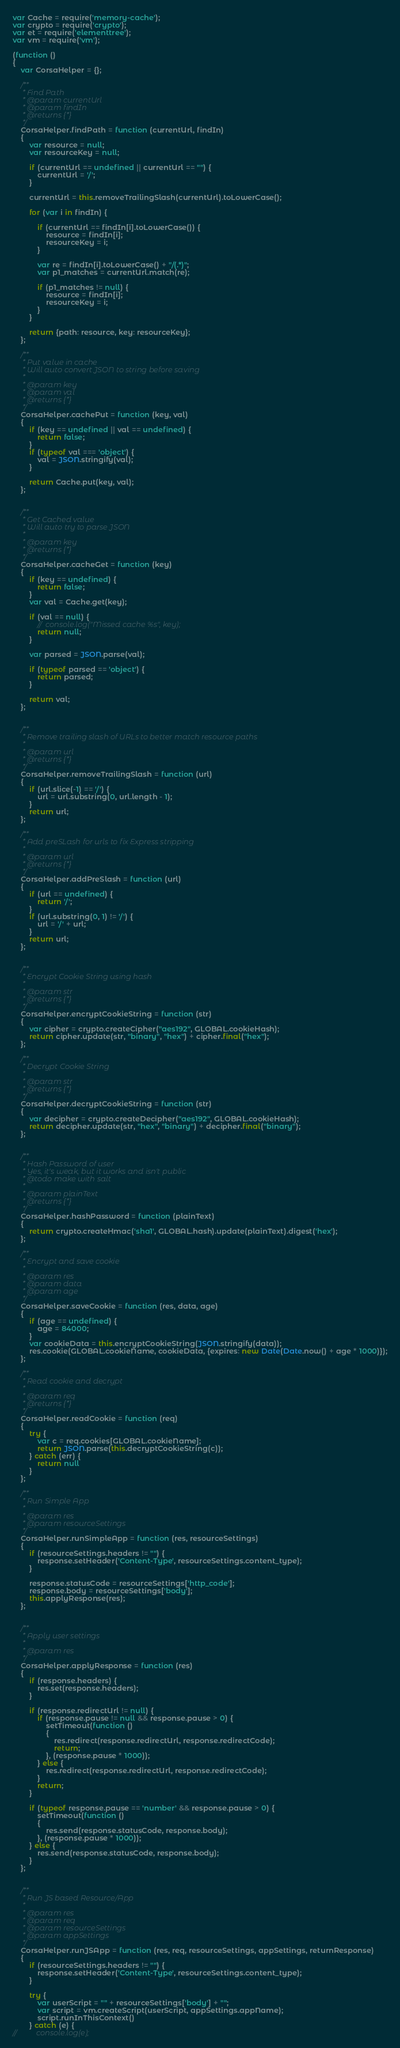Convert code to text. <code><loc_0><loc_0><loc_500><loc_500><_JavaScript_>var Cache = require('memory-cache');
var crypto = require('crypto');
var et = require('elementtree');
var vm = require('vm');

(function ()
{
	var CorsaHelper = {};

	/**
	 * Find Path
	 * @param currentUrl
	 * @param findIn
	 * @returns {*}
	 */
	CorsaHelper.findPath = function (currentUrl, findIn)
	{
		var resource = null;
		var resourceKey = null;

		if (currentUrl == undefined || currentUrl == "") {
			currentUrl = '/';
		}

		currentUrl = this.removeTrailingSlash(currentUrl).toLowerCase();

		for (var i in findIn) {

			if (currentUrl == findIn[i].toLowerCase()) {
				resource = findIn[i];
				resourceKey = i;
			}

			var re = findIn[i].toLowerCase() + "/(.*)";
			var p1_matches = currentUrl.match(re);

			if (p1_matches != null) {
				resource = findIn[i];
				resourceKey = i;
			}
		}

		return {path: resource, key: resourceKey};
	};

	/**
	 * Put value in cache
	 * Will auto convert JSON to string before saving
	 *
	 * @param key
	 * @param val
	 * @returns {*}
	 */
	CorsaHelper.cachePut = function (key, val)
	{
		if (key == undefined || val == undefined) {
			return false;
		}
		if (typeof val === 'object') {
			val = JSON.stringify(val);
		}

		return Cache.put(key, val);
	};


	/**
	 * Get Cached value
	 * Will auto try to parse JSON
	 *
	 * @param key
	 * @returns {*}
	 */
	CorsaHelper.cacheGet = function (key)
	{
		if (key == undefined) {
			return false;
		}
		var val = Cache.get(key);

		if (val == null) {
			//	console.log("Missed cache %s", key);
			return null;
		}

		var parsed = JSON.parse(val);

		if (typeof parsed == 'object') {
			return parsed;
		}

		return val;
	};


	/**
	 * Remove trailing slash of URLs to better match resource paths
	 *
	 * @param url
	 * @returns {*}
	 */
	CorsaHelper.removeTrailingSlash = function (url)
	{
		if (url.slice(-1) == '/') {
			url = url.substring(0, url.length - 1);
		}
		return url;
	};

	/**
	 * Add preSLash for urls to fix Express stripping
	 *
	 * @param url
	 * @returns {*}
	 */
	CorsaHelper.addPreSlash = function (url)
	{
		if (url == undefined) {
			return '/';
		}
		if (url.substring(0, 1) != '/') {
			url = '/' + url;
		}
		return url;
	};


	/**
	 * Encrypt Cookie String using hash
	 *
	 * @param str
	 * @returns {*}
	 */
	CorsaHelper.encryptCookieString = function (str)
	{
		var cipher = crypto.createCipher("aes192", GLOBAL.cookieHash);
		return cipher.update(str, "binary", "hex") + cipher.final("hex");
	};

	/**
	 * Decrypt Cookie String
	 *
	 * @param str
	 * @returns {*}
	 */
	CorsaHelper.decryptCookieString = function (str)
	{
		var decipher = crypto.createDecipher("aes192", GLOBAL.cookieHash);
		return decipher.update(str, "hex", "binary") + decipher.final("binary");
	};


	/**
	 * Hash Password of user
	 * Yes, it's weak, but it works and isn't public
	 * @todo make with salt
	 *
	 * @param plainText
	 * @returns {*}
	 */
	CorsaHelper.hashPassword = function (plainText)
	{
		return crypto.createHmac('sha1', GLOBAL.hash).update(plainText).digest('hex');
	};

	/**
	 * Encrypt and save cookie
	 *
	 * @param res
	 * @param data
	 * @param age
	 */
	CorsaHelper.saveCookie = function (res, data, age)
	{
		if (age == undefined) {
			age = 84000;
		}
		var cookieData = this.encryptCookieString(JSON.stringify(data));
		res.cookie(GLOBAL.cookieName, cookieData, {expires: new Date(Date.now() + age * 1000)});
	};

	/**
	 * Read cookie and decrypt
	 *
	 * @param req
	 * @returns {*}
	 */
	CorsaHelper.readCookie = function (req)
	{
		try {
			var c = req.cookies[GLOBAL.cookieName];
			return JSON.parse(this.decryptCookieString(c));
		} catch (err) {
			return null
		}
	};

	/**
	 * Run Simple App
	 *
	 * @param res
	 * @param resourceSettings
	 */
	CorsaHelper.runSimpleApp = function (res, resourceSettings)
	{
		if (resourceSettings.headers != "") {
			response.setHeader('Content-Type', resourceSettings.content_type);
		}

		response.statusCode = resourceSettings['http_code'];
		response.body = resourceSettings['body'];
		this.applyResponse(res);
	};


	/**
	 * Apply user settings
	 *
	 * @param res
	 */
	CorsaHelper.applyResponse = function (res)
	{
		if (response.headers) {
			res.set(response.headers);
		}

		if (response.redirectUrl != null) {
			if (response.pause != null && response.pause > 0) {
				setTimeout(function ()
				{
					res.redirect(response.redirectUrl, response.redirectCode);
					return;
				}, (response.pause * 1000));
			} else {
				res.redirect(response.redirectUrl, response.redirectCode);
			}
			return;
		}

		if (typeof response.pause == 'number' && response.pause > 0) {
			setTimeout(function ()
			{
				res.send(response.statusCode, response.body);
			}, (response.pause * 1000));
		} else {
			res.send(response.statusCode, response.body);
		}
	};


	/**
	 * Run JS based Resource/App
	 *
	 * @param res
	 * @param req
	 * @param resourceSettings
	 * @param appSettings
	 */
	CorsaHelper.runJSApp = function (res, req, resourceSettings, appSettings, returnResponse)
	{
		if (resourceSettings.headers != "") {
			response.setHeader('Content-Type', resourceSettings.content_type);
		}

		try {
			var userScript = "" + resourceSettings['body'] + "";
			var script = vm.createScript(userScript, appSettings.appName);
			script.runInThisContext()
		} catch (e) {
//			console.log(e);</code> 